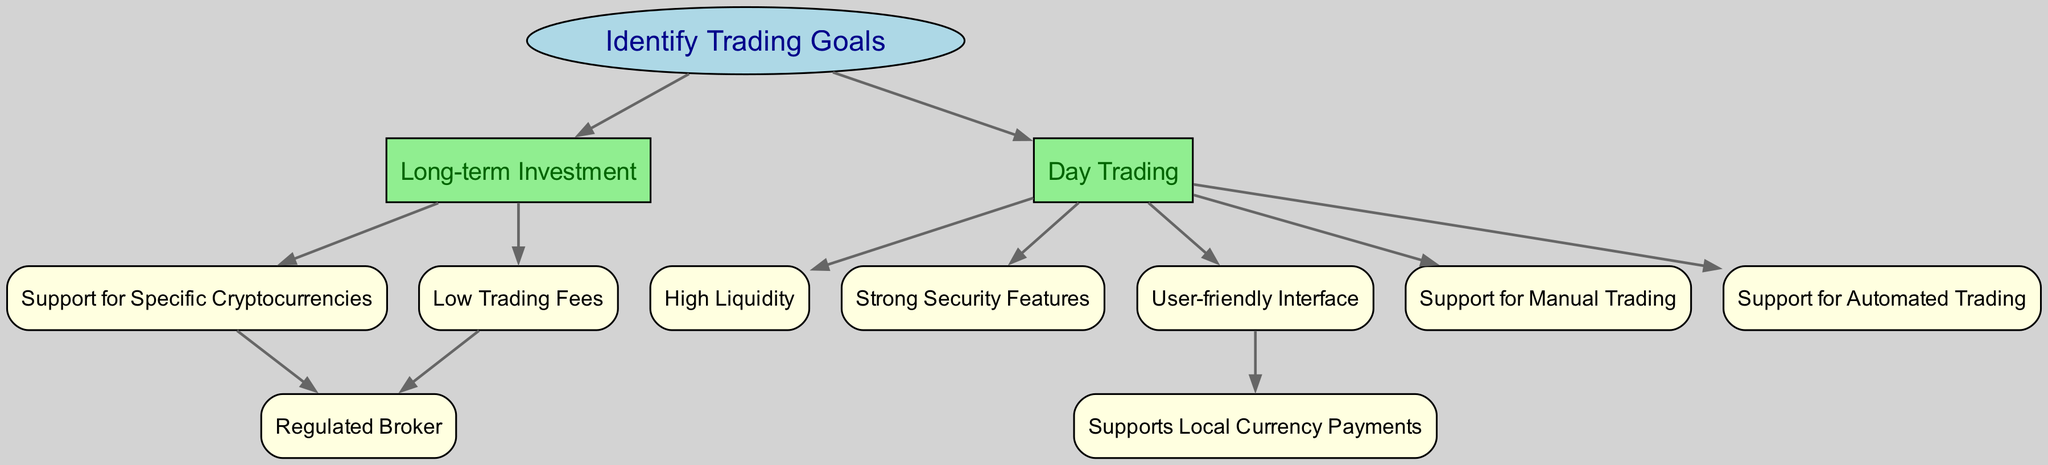What is the starting point of this decision tree? The starting point is labeled “Identify Trading Goals,” as indicated by the first node in the diagram.
Answer: Identify Trading Goals How many main trading goals are identified in the diagram? There are two main trading goals identified: “Long-term Investment” and “Day Trading.” These are the primary branches stemming from the starting point.
Answer: 2 Which node leads to the option of a regulated broker? There are two nodes that lead to the option of a regulated broker: “Support for Specific Cryptocurrencies” and “Low Trading Fees.” Both nodes have directed edges connecting to the “Regulated Broker” node.
Answer: Support for Specific Cryptocurrencies, Low Trading Fees What are the features associated with "Day Trading"? The “Day Trading” node connects to five features: “High Liquidity,” “User-friendly Interface,” “Support for Manual Trading,” “Support for Automated Trading,” and “Strong Security Features.”
Answer: High Liquidity, User-friendly Interface, Support for Manual Trading, Support for Automated Trading, Strong Security Features If the goal is "Long-term Investment," which nodes are considered next? If the goal is “Long-term Investment,” the next nodes to consider are “Support for Specific Cryptocurrencies” and “Low Trading Fees,” as these are directly connected to the “Long-term Investment” node.
Answer: Support for Specific Cryptocurrencies, Low Trading Fees How many edges connect the nodes in this diagram? To find the number of edges, count the connections between all nodes: there are a total of 11 edges connecting the nodes in the diagram.
Answer: 11 Which node improves user-friendliness that also connects to local currency payments? The node that improves user-friendliness is “User-friendly Interface,” which connects to “Supports Local Currency Payments” through the directed edge that leads from it.
Answer: User-friendly Interface What type of brokerage do the “Low Trading Fees” and “Support for Specific Cryptocurrencies” nodes lead to? Both nodes lead to the option of a “Regulated Broker,” indicating that these features are associated with choosing a reputable brokerage.
Answer: Regulated Broker 